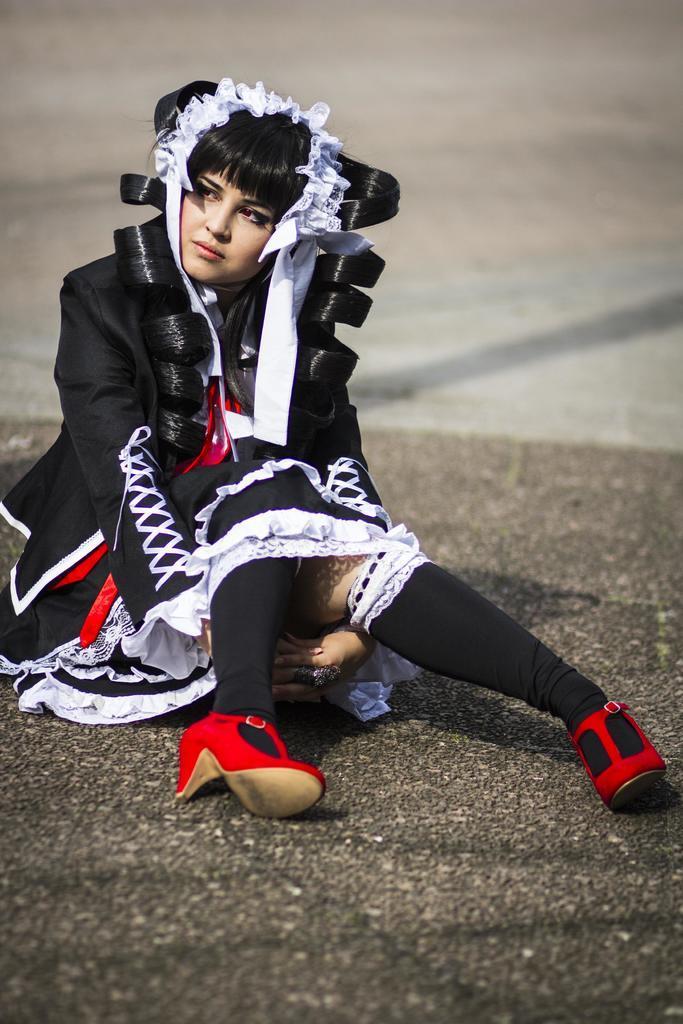Can you describe this image briefly? In this image we can see a woman sitting on the road. 